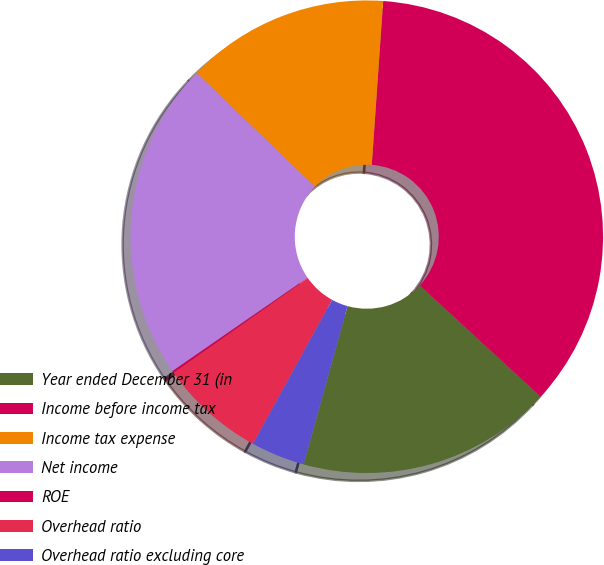<chart> <loc_0><loc_0><loc_500><loc_500><pie_chart><fcel>Year ended December 31 (in<fcel>Income before income tax<fcel>Income tax expense<fcel>Net income<fcel>ROE<fcel>Overhead ratio<fcel>Overhead ratio excluding core<nl><fcel>17.47%<fcel>35.73%<fcel>13.91%<fcel>21.82%<fcel>0.13%<fcel>7.25%<fcel>3.69%<nl></chart> 